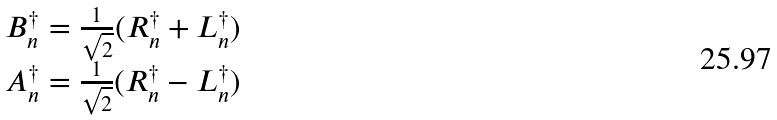Convert formula to latex. <formula><loc_0><loc_0><loc_500><loc_500>\begin{array} { c } B ^ { \dagger } _ { n } = \frac { 1 } { \sqrt { 2 } } ( R ^ { \dagger } _ { n } + L ^ { \dagger } _ { n } ) \\ A ^ { \dagger } _ { n } = \frac { 1 } { \sqrt { 2 } } ( R ^ { \dagger } _ { n } - L ^ { \dagger } _ { n } ) \end{array}</formula> 